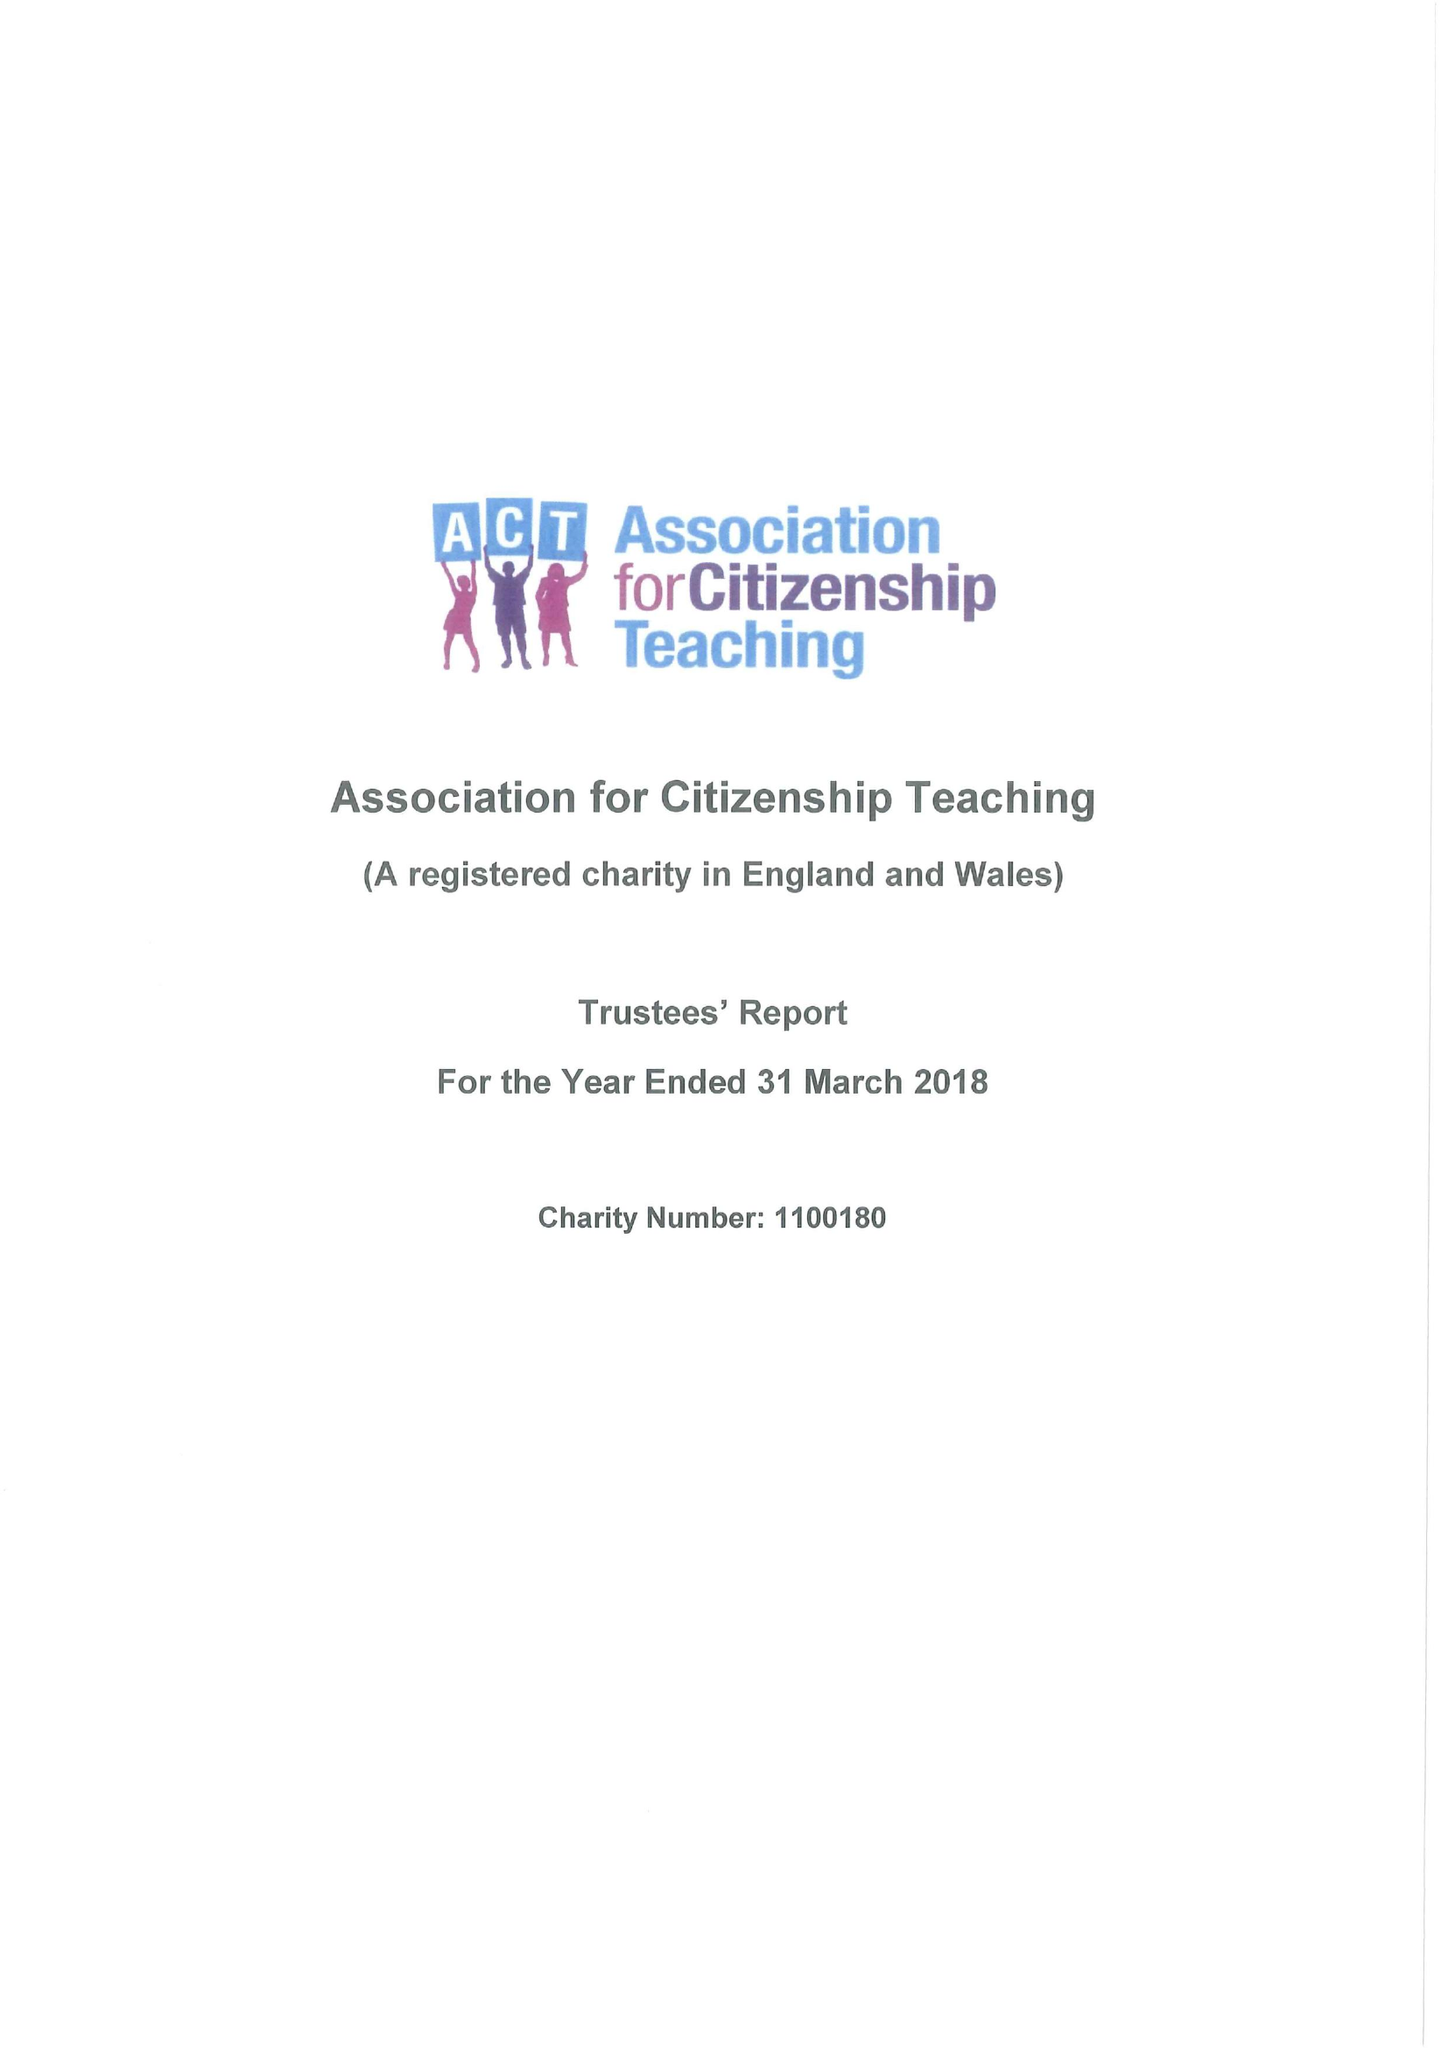What is the value for the report_date?
Answer the question using a single word or phrase. 2018-03-31 